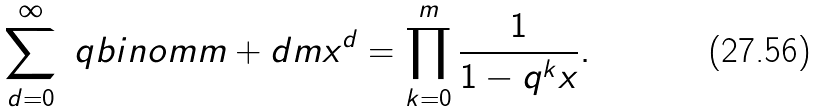Convert formula to latex. <formula><loc_0><loc_0><loc_500><loc_500>\sum _ { d = 0 } ^ { \infty } \ q b i n o m { m + d } { m } x ^ { d } = \prod _ { k = 0 } ^ { m } \frac { 1 } { 1 - q ^ { k } x } .</formula> 